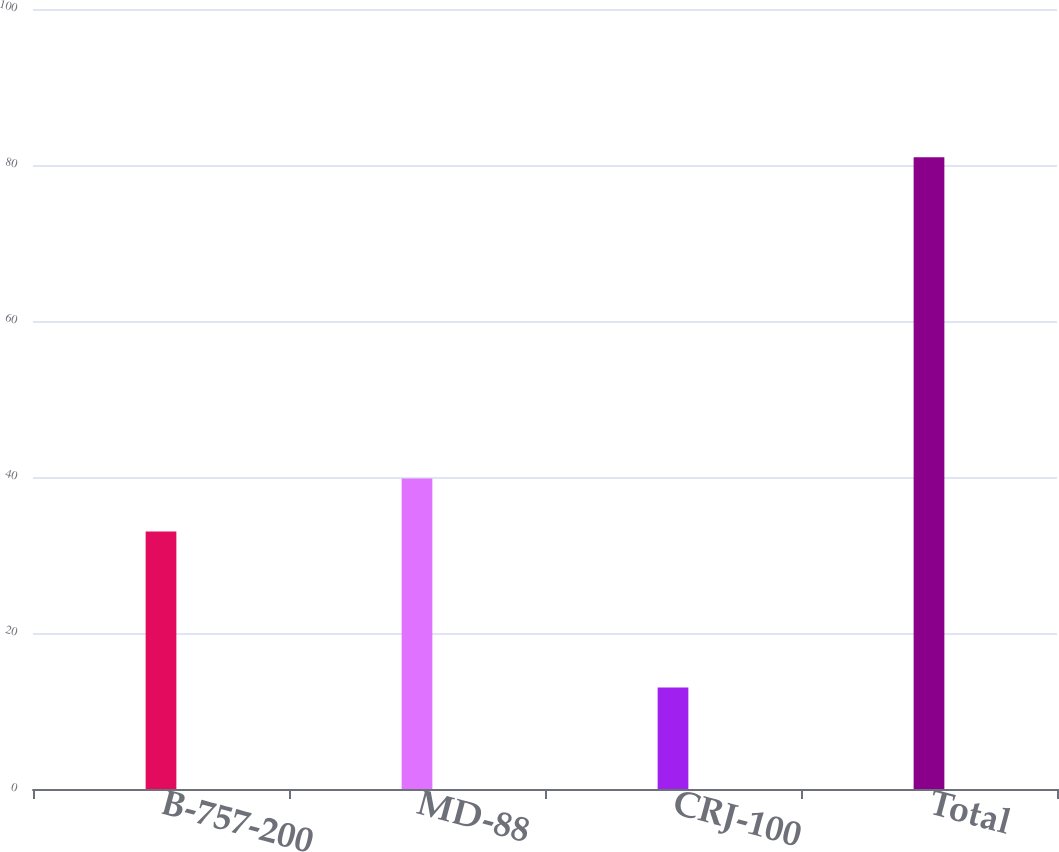Convert chart. <chart><loc_0><loc_0><loc_500><loc_500><bar_chart><fcel>B-757-200<fcel>MD-88<fcel>CRJ-100<fcel>Total<nl><fcel>33<fcel>39.8<fcel>13<fcel>81<nl></chart> 